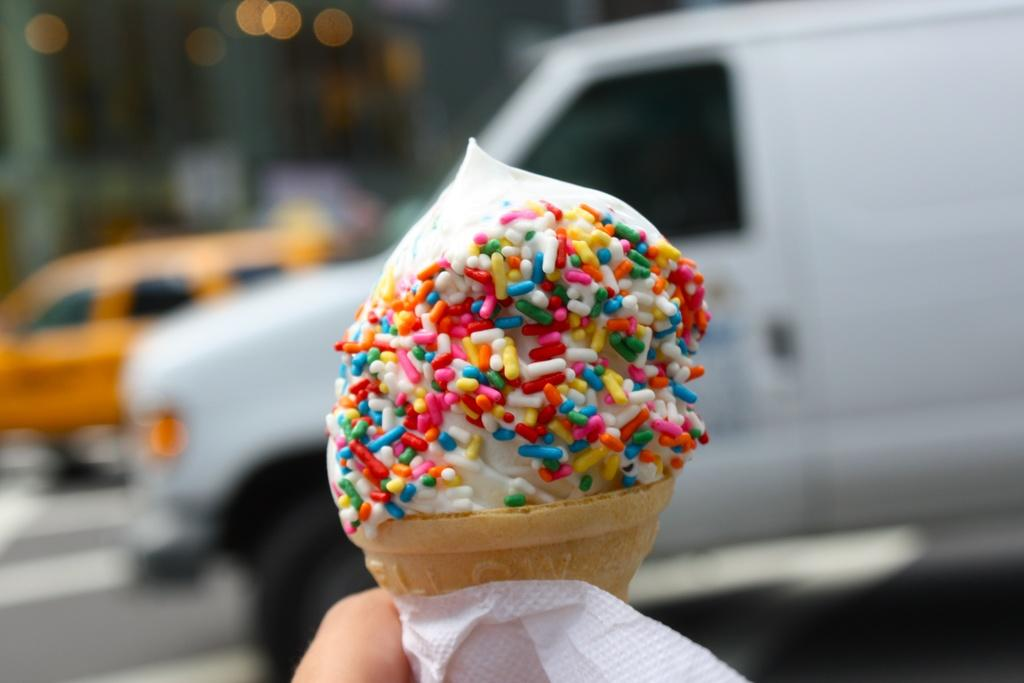Who is in the image? There is a person in the image. What is the person holding? The person is holding an ice cream. What else can be seen in the image besides the person and the ice cream? Tissue paper is present in the image. Can you describe the background of the image? The background of the image is blurred, and there are vehicles, a road, and lights visible. What type of mist is covering the person in the image? There is no mist present in the image; the background is blurred, but the person is not covered by any mist. 